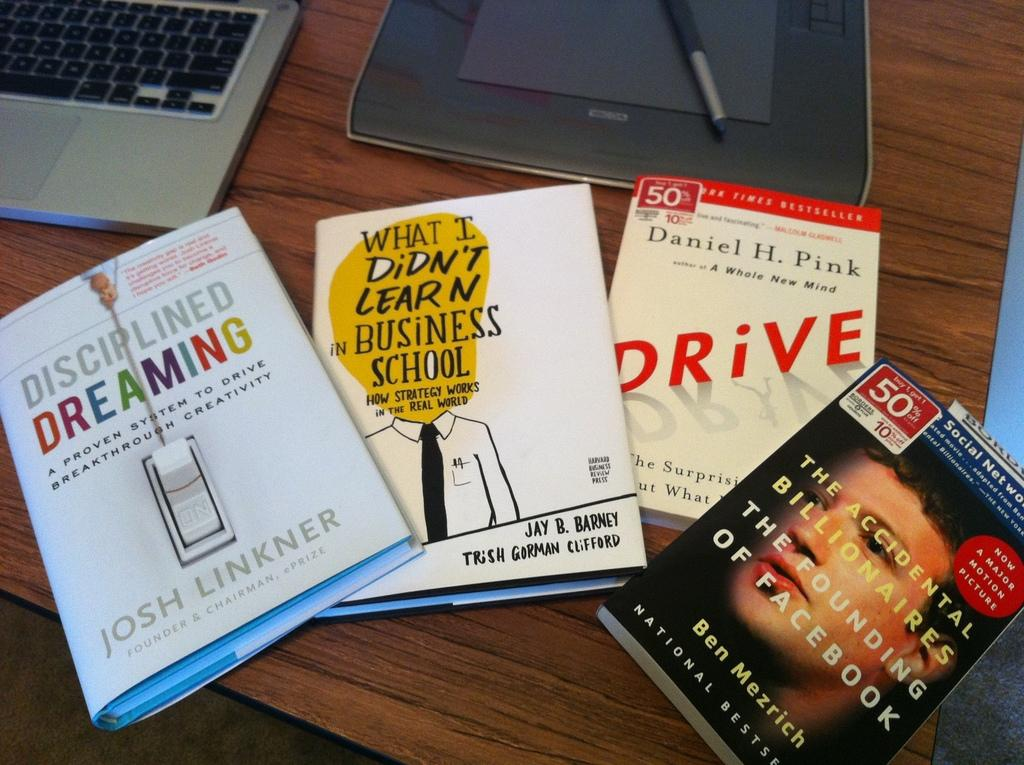<image>
Give a short and clear explanation of the subsequent image. A stack of books including Disciplined Dreaming on a desk by a laptop. 